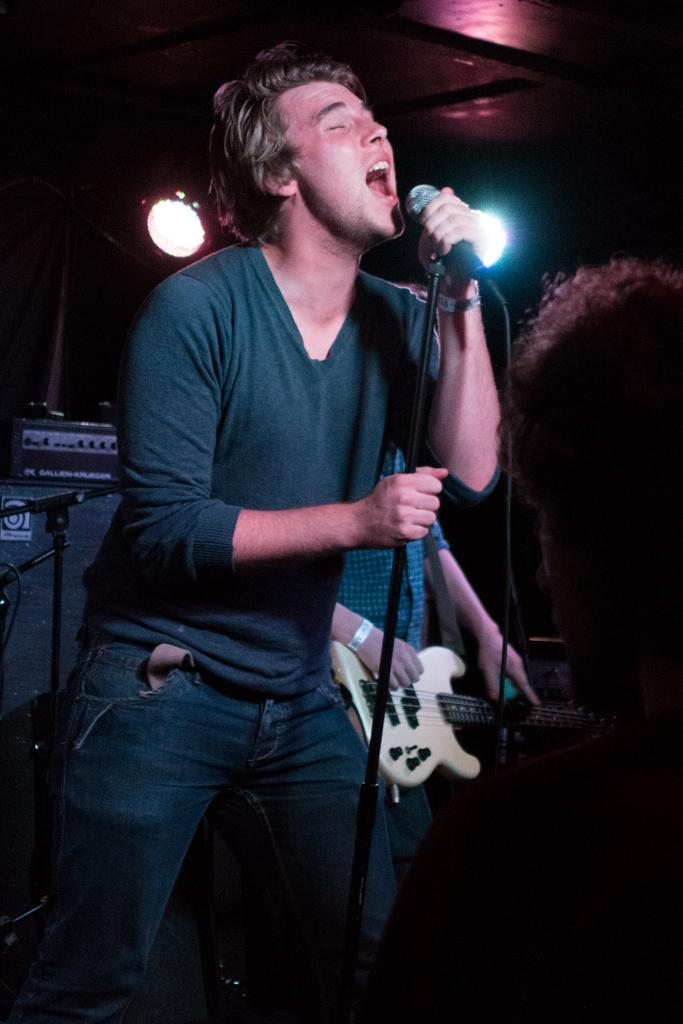What is the main subject of the image? The main subject of the image is a man. What is the man doing in the image? The man is standing, singing, and using a microphone. What instrument is the man holding in the image? The man is holding a guitar in his hand. What type of paste is the man using to stick the pest to the picture in the image? There is no paste, pest, or picture present in the image; the man is holding a guitar and using a microphone to sing. 